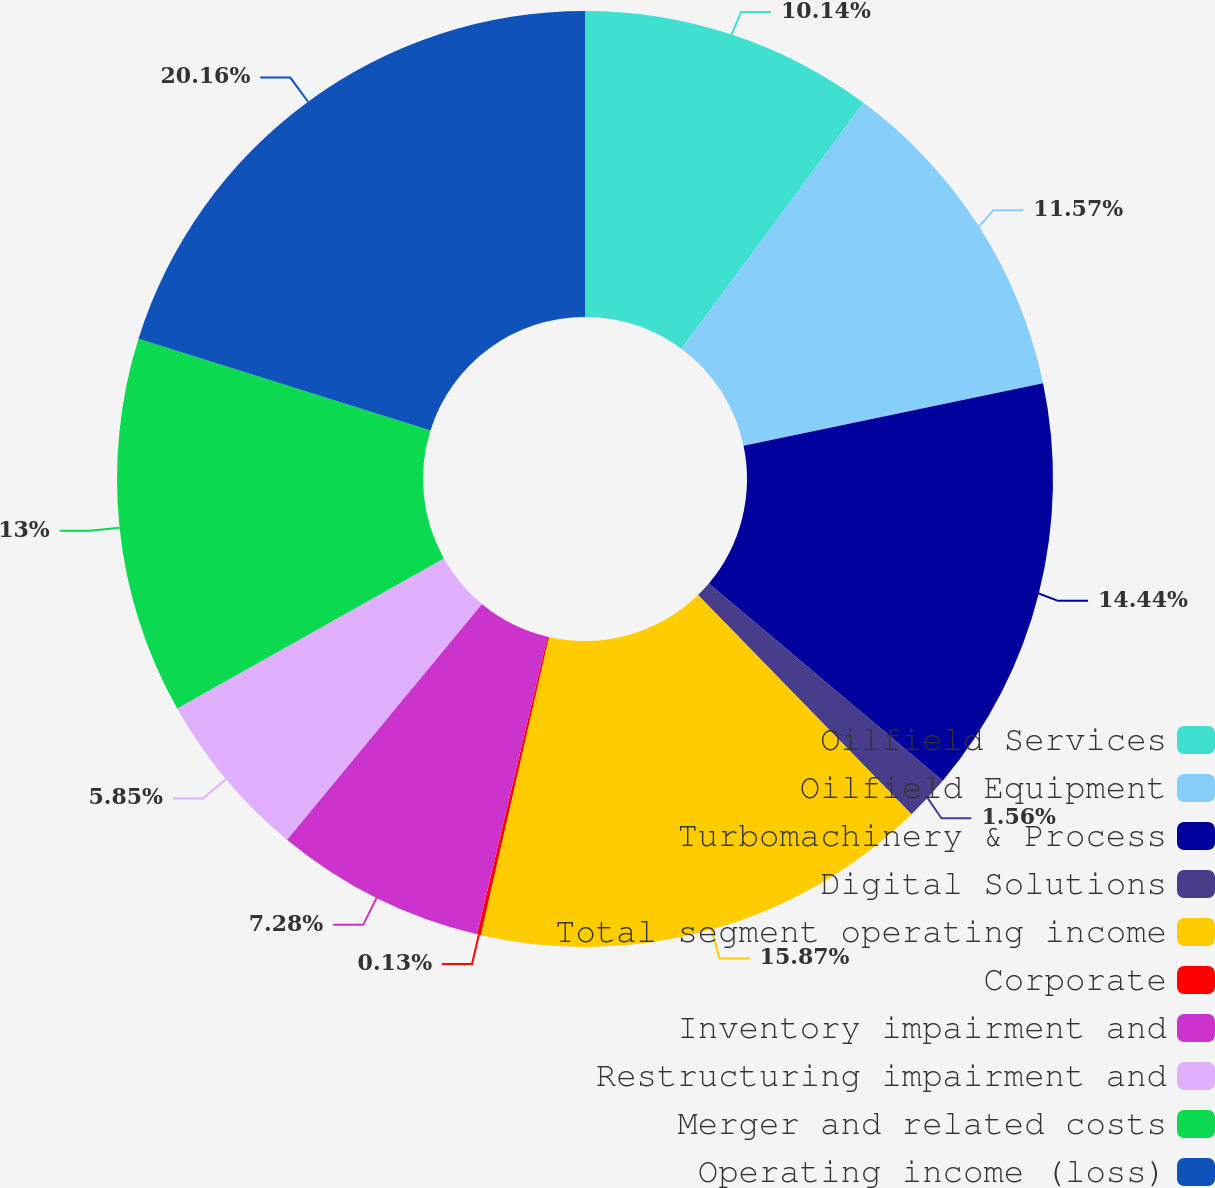<chart> <loc_0><loc_0><loc_500><loc_500><pie_chart><fcel>Oilfield Services<fcel>Oilfield Equipment<fcel>Turbomachinery & Process<fcel>Digital Solutions<fcel>Total segment operating income<fcel>Corporate<fcel>Inventory impairment and<fcel>Restructuring impairment and<fcel>Merger and related costs<fcel>Operating income (loss)<nl><fcel>10.14%<fcel>11.57%<fcel>14.43%<fcel>1.56%<fcel>15.86%<fcel>0.13%<fcel>7.28%<fcel>5.85%<fcel>13.0%<fcel>20.15%<nl></chart> 